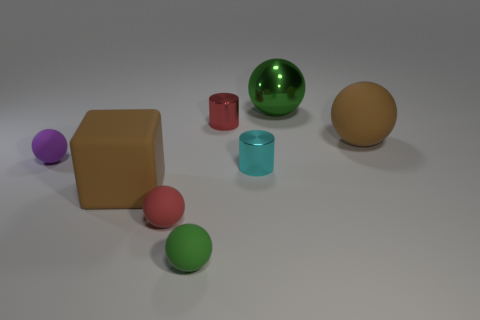Subtract all tiny purple matte balls. How many balls are left? 4 Subtract 4 balls. How many balls are left? 1 Subtract all cylinders. How many objects are left? 6 Subtract all brown balls. How many balls are left? 4 Add 6 cyan metal cylinders. How many cyan metal cylinders are left? 7 Add 4 cyan shiny objects. How many cyan shiny objects exist? 5 Add 1 metal cylinders. How many objects exist? 9 Subtract 0 cyan spheres. How many objects are left? 8 Subtract all red balls. Subtract all brown cubes. How many balls are left? 4 Subtract all brown cubes. How many cyan balls are left? 0 